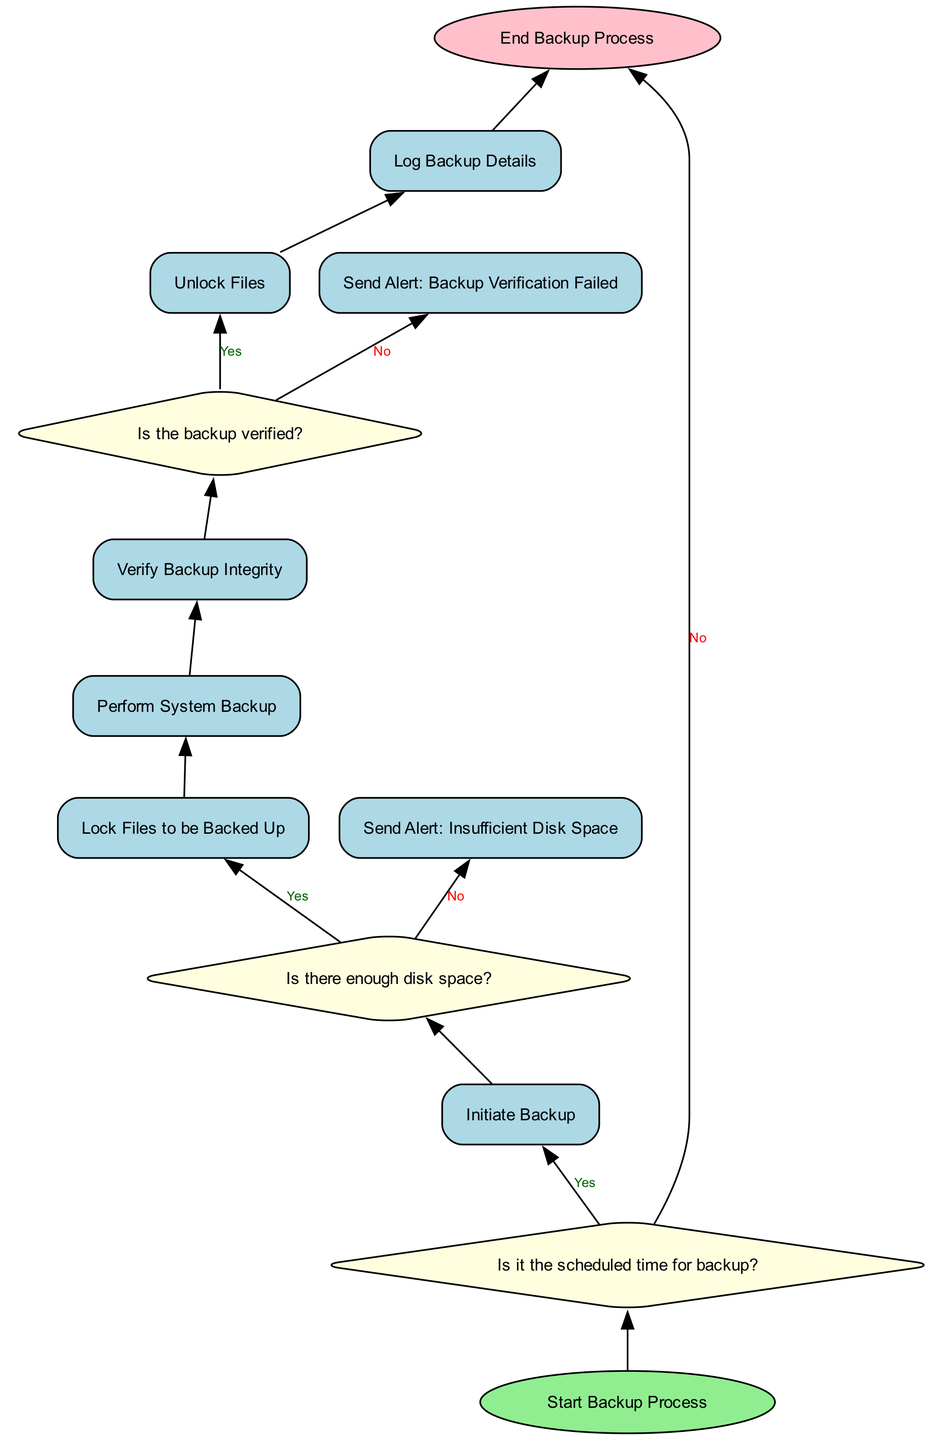What is the first step in the backup process? The diagram specifies that the first step in the backup process is "Start Backup Process," which is represented as the starting node in the flowchart.
Answer: Start Backup Process What happens if it is not the scheduled time for backup? According to the flowchart, if it is not the scheduled time for backup, the next step leads to the "End Backup Process," indicating that no further actions are taken.
Answer: End Backup Process How many decision points are present in the diagram? The diagram contains three decision points: "Is it the scheduled time for backup?", "Is there enough disk space?", and "Is the backup verified?" Therefore, counting these points gives us a total of three.
Answer: Three What is the action taken if there is insufficient disk space? The flowchart indicates that if there is insufficient disk space, the action taken is to "Send Alert: Insufficient Disk Space," and then it moves to the end of the process.
Answer: Send Alert: Insufficient Disk Space What is the last process that occurs before ending the backup process? The last process before ending the backup process, as shown in the diagram, is "Log Backup Details," which captures the details of the backup performed.
Answer: Log Backup Details What paths can be taken after the backup verification check? Following the backup verification check, if the backup is verified, the process will continue to "Unlock Files." If the backup is not verified, it will lead to "Send Alert: Backup Verification Failed," followed by the end of the process. This shows two possible paths based on the verification result.
Answer: Unlock Files or Send Alert: Backup Verification Failed What is the consequence of failing the backup verification? The consequence of failing the backup verification is that an alert is sent indicating "Backup Verification Failed," and then the flow proceeds to the end of the backup process.
Answer: Send Alert: Backup Verification Failed What is the decision point that occurs immediately after "Initiate Backup"? Right after "Initiate Backup", the next decision point is "Is there enough disk space?", which checks the availability of sufficient disk space for performing the backup.
Answer: Is there enough disk space? 